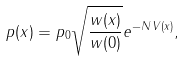Convert formula to latex. <formula><loc_0><loc_0><loc_500><loc_500>p ( x ) = p _ { 0 } \sqrt { \frac { w ( x ) } { w ( 0 ) } } e ^ { - N \, V ( x ) } ,</formula> 